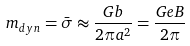<formula> <loc_0><loc_0><loc_500><loc_500>m _ { d y n } = \bar { \sigma } \approx \frac { G b } { 2 \pi a ^ { 2 } } = \frac { G e B } { 2 \pi }</formula> 